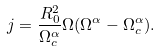Convert formula to latex. <formula><loc_0><loc_0><loc_500><loc_500>j = \frac { R _ { 0 } ^ { 2 } } { \Omega _ { c } ^ { \alpha } } \Omega ( \Omega ^ { \alpha } - \Omega _ { c } ^ { \alpha } ) .</formula> 